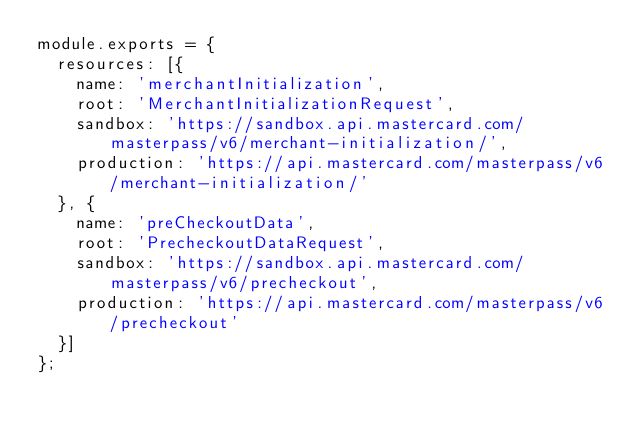Convert code to text. <code><loc_0><loc_0><loc_500><loc_500><_JavaScript_>module.exports = {
	resources: [{
		name: 'merchantInitialization',
		root: 'MerchantInitializationRequest',
		sandbox: 'https://sandbox.api.mastercard.com/masterpass/v6/merchant-initialization/',
		production: 'https://api.mastercard.com/masterpass/v6/merchant-initialization/'
	}, {
		name: 'preCheckoutData',
		root: 'PrecheckoutDataRequest',
		sandbox: 'https://sandbox.api.mastercard.com/masterpass/v6/precheckout', 
		production: 'https://api.mastercard.com/masterpass/v6/precheckout'
	}]
};</code> 